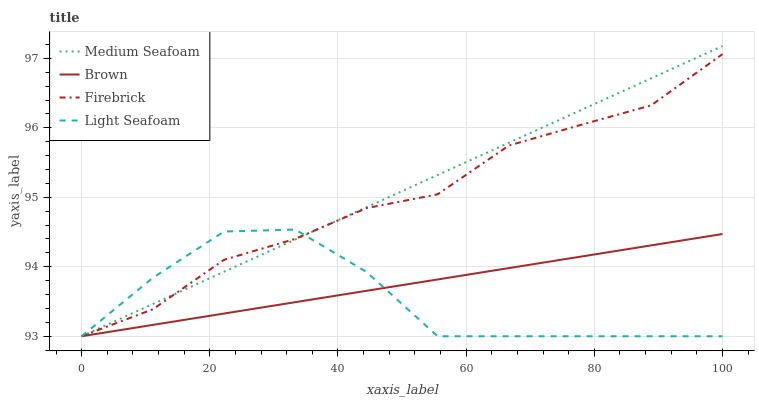Does Firebrick have the minimum area under the curve?
Answer yes or no. No. Does Firebrick have the maximum area under the curve?
Answer yes or no. No. Is Firebrick the smoothest?
Answer yes or no. No. Is Firebrick the roughest?
Answer yes or no. No. Does Firebrick have the highest value?
Answer yes or no. No. 